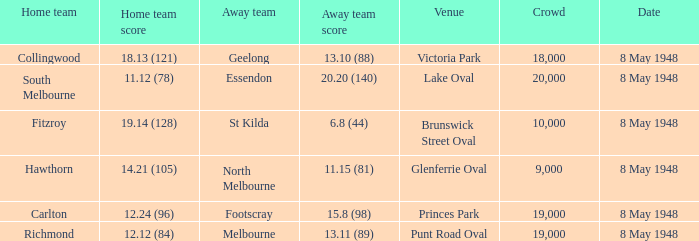How many spectators were at the game when the away team scored 15.8 (98)? 19000.0. 